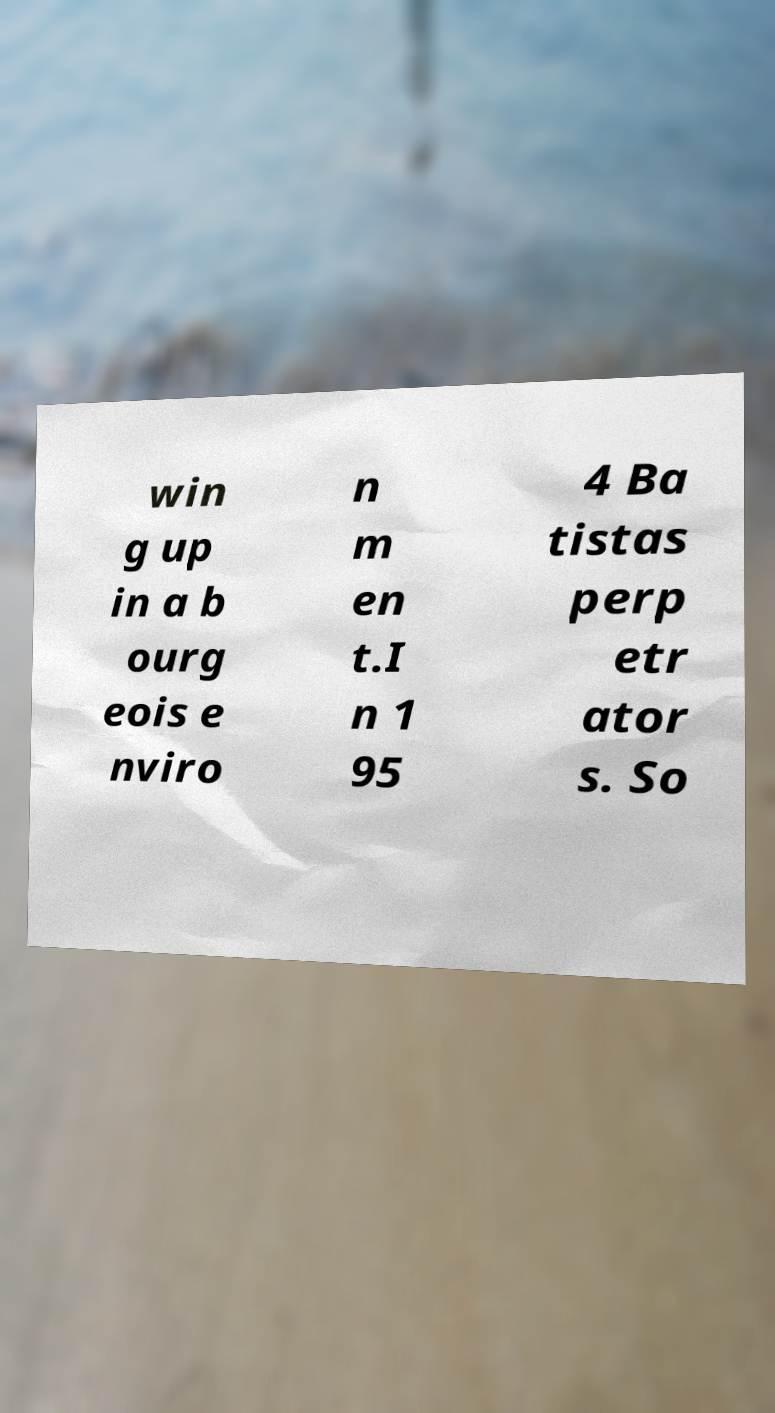Could you assist in decoding the text presented in this image and type it out clearly? win g up in a b ourg eois e nviro n m en t.I n 1 95 4 Ba tistas perp etr ator s. So 